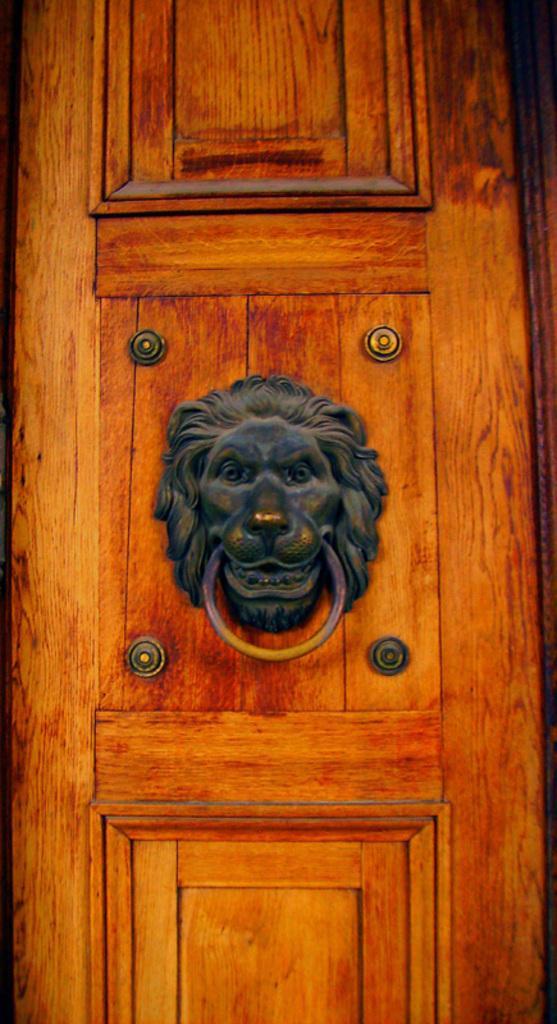Can you describe this image briefly? In this picture I can see a lion head door knocker attached to the door. 